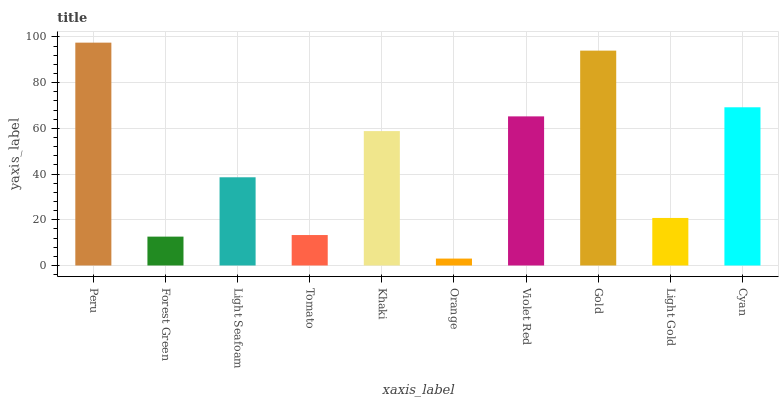Is Orange the minimum?
Answer yes or no. Yes. Is Peru the maximum?
Answer yes or no. Yes. Is Forest Green the minimum?
Answer yes or no. No. Is Forest Green the maximum?
Answer yes or no. No. Is Peru greater than Forest Green?
Answer yes or no. Yes. Is Forest Green less than Peru?
Answer yes or no. Yes. Is Forest Green greater than Peru?
Answer yes or no. No. Is Peru less than Forest Green?
Answer yes or no. No. Is Khaki the high median?
Answer yes or no. Yes. Is Light Seafoam the low median?
Answer yes or no. Yes. Is Peru the high median?
Answer yes or no. No. Is Cyan the low median?
Answer yes or no. No. 